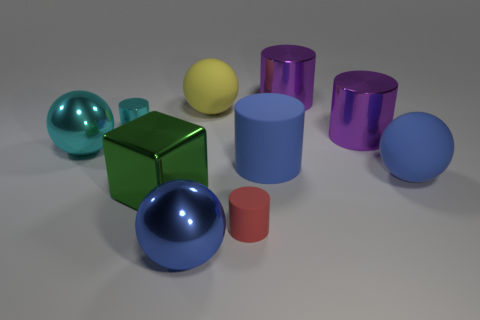Is the color of the tiny metal thing the same as the small thing to the right of the cyan metal cylinder?
Your answer should be compact. No. What number of cylinders are large blue things or tiny cyan metal objects?
Your answer should be very brief. 2. Is there anything else that has the same color as the big block?
Your response must be concise. No. There is a big blue thing left of the tiny cylinder that is on the right side of the yellow thing; what is its material?
Your answer should be very brief. Metal. Does the cyan sphere have the same material as the large purple cylinder behind the yellow rubber ball?
Your answer should be compact. Yes. How many objects are either cylinders that are in front of the large green metal block or red rubber cylinders?
Provide a succinct answer. 1. Are there any large matte cylinders that have the same color as the small matte cylinder?
Provide a succinct answer. No. There is a small matte thing; is its shape the same as the small thing behind the cyan ball?
Provide a short and direct response. Yes. What number of metallic things are to the right of the green shiny thing and on the left side of the large cube?
Give a very brief answer. 0. What is the material of the other blue thing that is the same shape as the tiny rubber thing?
Provide a succinct answer. Rubber. 